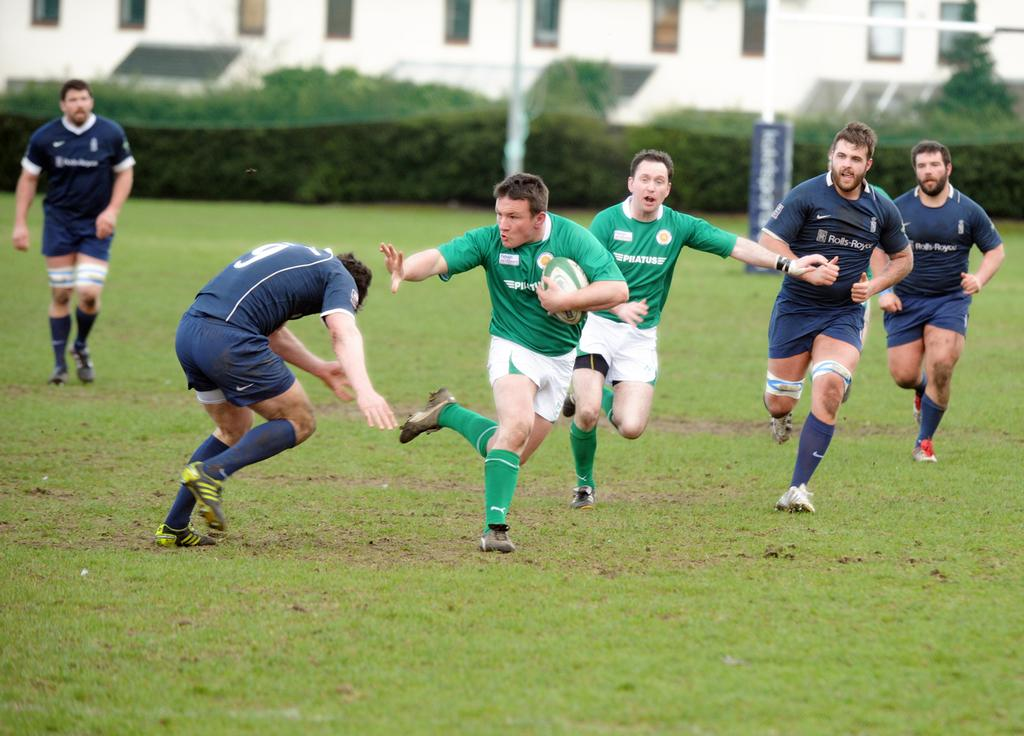What type of structure can be seen in the background of the image? There is a building with windows in the background. What else is visible in the image besides the building? There are plants and men playing a Rugby game on the ground. How would you describe the condition of the grass in the image? The grass is fresh and green. What type of cabbage is being used as a ball in the Rugby game? There is no cabbage present in the image; the men are playing with a Rugby ball. What substance is being folded by the players during the game? There is no folding or substance mentioned in the image; the men are playing Rugby, which does not involve folding any materials. 